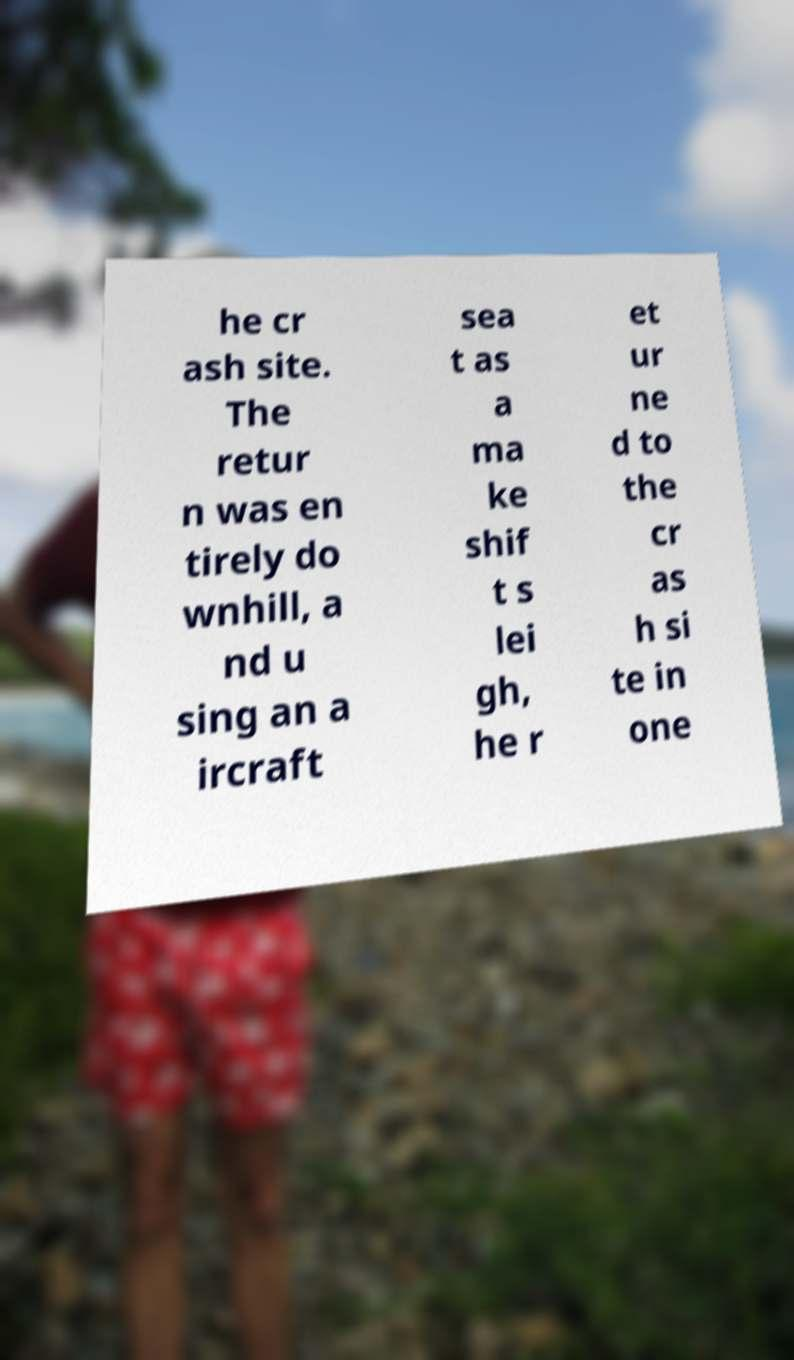Can you accurately transcribe the text from the provided image for me? he cr ash site. The retur n was en tirely do wnhill, a nd u sing an a ircraft sea t as a ma ke shif t s lei gh, he r et ur ne d to the cr as h si te in one 